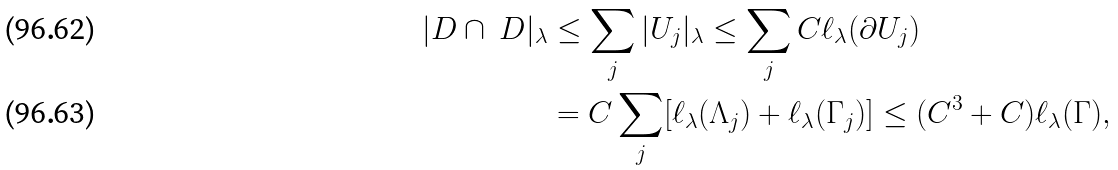<formula> <loc_0><loc_0><loc_500><loc_500>| D \cap \ D | _ { \lambda } & \leq \sum _ { j } | U _ { j } | _ { \lambda } \leq \sum _ { j } C \ell _ { \lambda } ( \partial U _ { j } ) \\ & = C \sum _ { j } [ \ell _ { \lambda } ( \Lambda _ { j } ) + \ell _ { \lambda } ( \Gamma _ { j } ) ] \leq ( C ^ { 3 } + C ) \ell _ { \lambda } ( \Gamma ) ,</formula> 